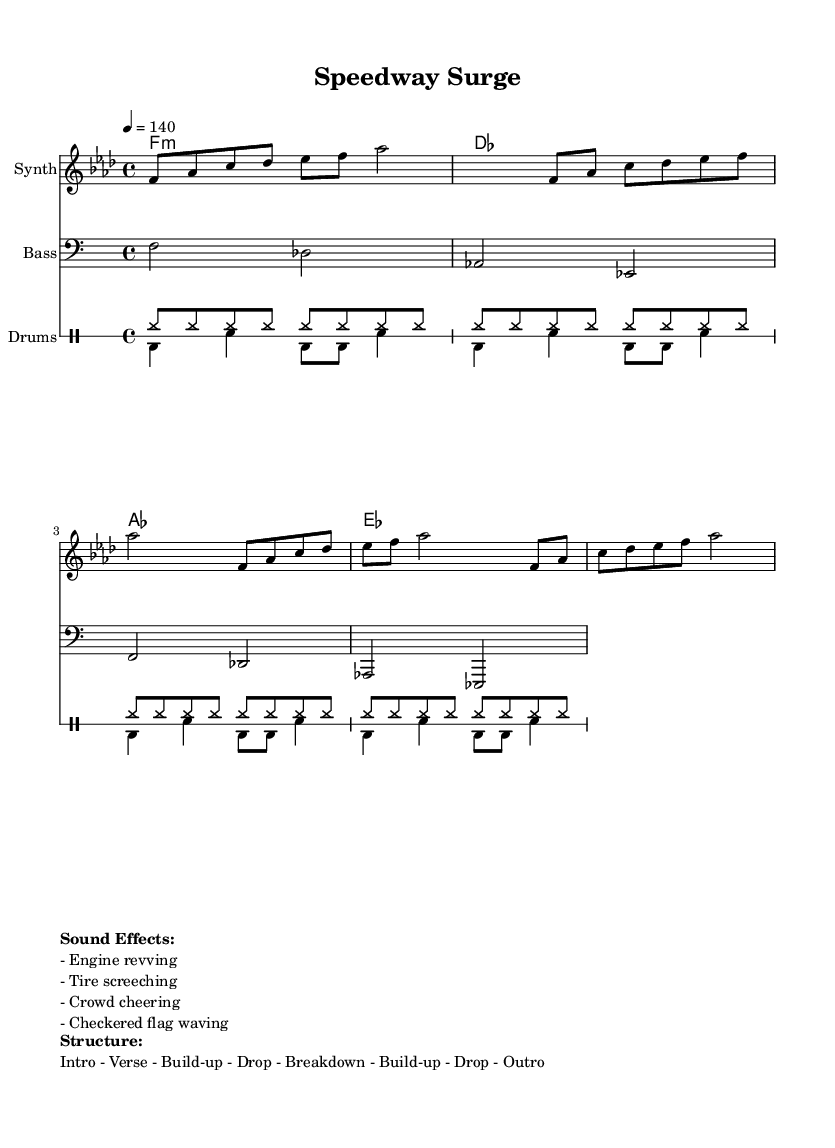What is the key signature of this music? The key signature is indicated at the beginning of the staff. It shows a flat on the B line, indicating that the piece is in F minor.
Answer: F minor What is the time signature of this music? The time signature is shown at the beginning of the score, which is 4/4, meaning there are four beats in each measure and the quarter note gets one beat.
Answer: 4/4 What is the tempo marking of this piece? The tempo marking can be found next to the time signature and indicates the speed of the piece, which is set at 140 beats per minute (4 = 140).
Answer: 140 What instruments are featured in this score? The instruments are listed in the score where each staff is defined. The instruments are Synth for the melody, Bass for the bass line, and Drums for the drum patterns.
Answer: Synth, Bass, Drums How does the structure of the piece unfold? The structure is noted in the markup section at the bottom. It follows a specific order of musical sections, which includes an Intro, Verse, Build-up, Drop, Breakdown, Build-up, Drop, and Outro.
Answer: Intro - Verse - Build-up - Drop - Breakdown - Build-up - Drop - Outro What sound effects are included in the music? The sound effects are listed in the markup section, which includes sounds that enhance the racing theme such as engine revving, tire screeching, crowd cheering, and a checkered flag waving.
Answer: Engine revving, Tire screeching, Crowd cheering, Checkered flag waving 